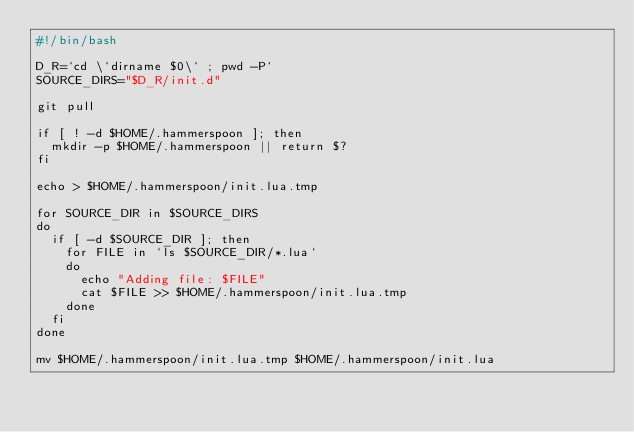Convert code to text. <code><loc_0><loc_0><loc_500><loc_500><_Bash_>#!/bin/bash

D_R=`cd \`dirname $0\` ; pwd -P`
SOURCE_DIRS="$D_R/init.d"

git pull

if [ ! -d $HOME/.hammerspoon ]; then
  mkdir -p $HOME/.hammerspoon || return $?
fi

echo > $HOME/.hammerspoon/init.lua.tmp

for SOURCE_DIR in $SOURCE_DIRS
do
  if [ -d $SOURCE_DIR ]; then
    for FILE in `ls $SOURCE_DIR/*.lua`
    do
      echo "Adding file: $FILE"
      cat $FILE >> $HOME/.hammerspoon/init.lua.tmp
    done
  fi
done

mv $HOME/.hammerspoon/init.lua.tmp $HOME/.hammerspoon/init.lua
</code> 